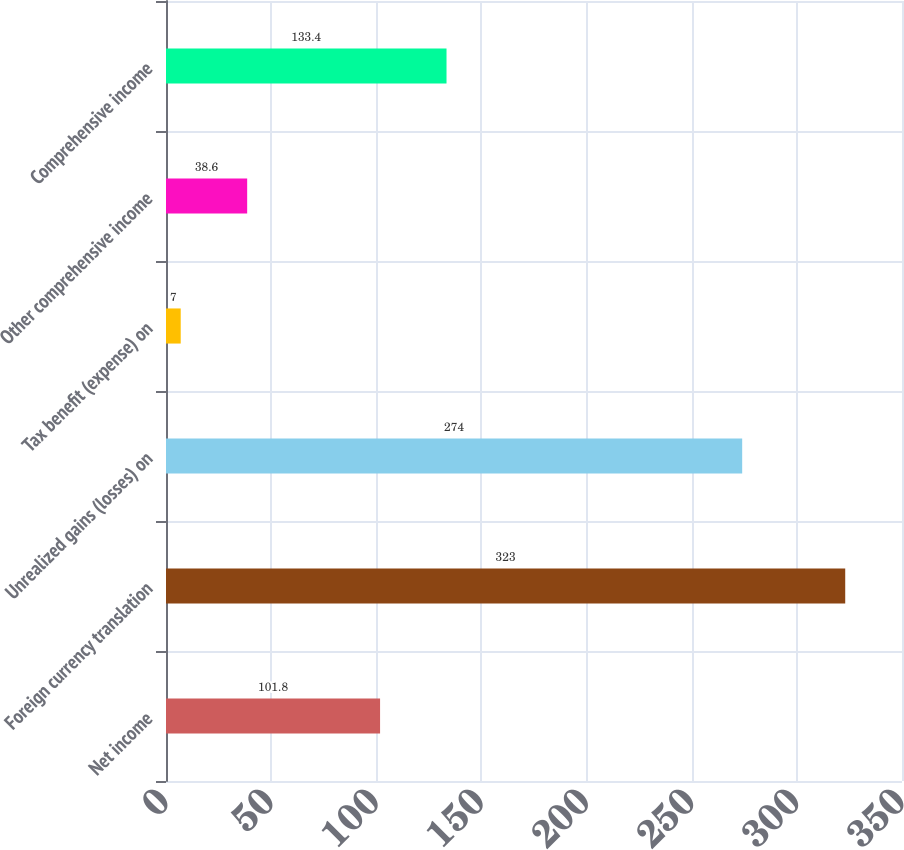Convert chart to OTSL. <chart><loc_0><loc_0><loc_500><loc_500><bar_chart><fcel>Net income<fcel>Foreign currency translation<fcel>Unrealized gains (losses) on<fcel>Tax benefit (expense) on<fcel>Other comprehensive income<fcel>Comprehensive income<nl><fcel>101.8<fcel>323<fcel>274<fcel>7<fcel>38.6<fcel>133.4<nl></chart> 